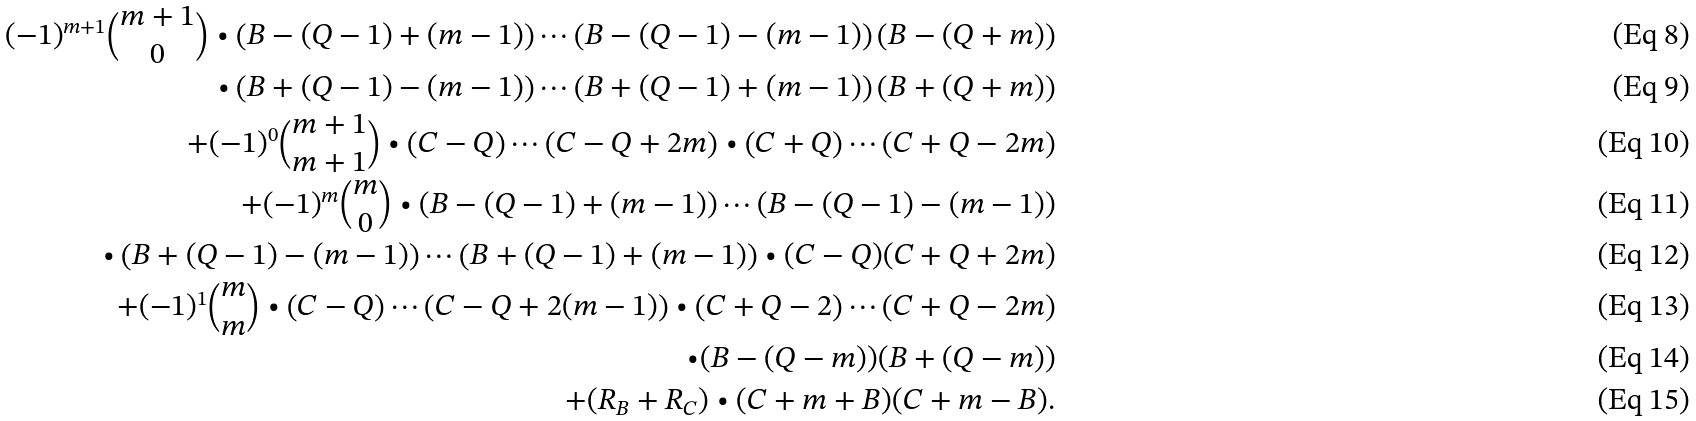Convert formula to latex. <formula><loc_0><loc_0><loc_500><loc_500>( - 1 ) ^ { m + 1 } \binom { m + 1 } { 0 } \bullet \left ( B - ( Q - 1 ) + ( m - 1 ) \right ) \cdots \left ( B - ( Q - 1 ) - ( m - 1 ) \right ) \left ( B - ( Q + m ) \right ) \\ \bullet \left ( B + ( Q - 1 ) - ( m - 1 ) \right ) \cdots \left ( B + ( Q - 1 ) + ( m - 1 ) \right ) \left ( B + ( Q + m ) \right ) \\ + ( - 1 ) ^ { 0 } \binom { m + 1 } { m + 1 } \bullet \left ( C - Q \right ) \cdots \left ( C - Q + 2 m \right ) \bullet \left ( C + Q \right ) \cdots \left ( C + Q - 2 m \right ) \\ + ( - 1 ) ^ { m } \binom { m } { 0 } \bullet \left ( B - ( Q - 1 ) + ( m - 1 ) \right ) \cdots \left ( B - ( Q - 1 ) - ( m - 1 ) \right ) \\ \bullet \left ( B + ( Q - 1 ) - ( m - 1 ) \right ) \cdots \left ( B + ( Q - 1 ) + ( m - 1 ) \right ) \bullet ( C - Q ) ( C + Q + 2 m ) \\ + ( - 1 ) ^ { 1 } \binom { m } { m } \bullet \left ( C - Q \right ) \cdots \left ( C - Q + 2 ( m - 1 ) \right ) \bullet \left ( C + Q - 2 \right ) \cdots \left ( C + Q - 2 m \right ) \\ \bullet ( B - ( Q - m ) ) ( B + ( Q - m ) ) \\ + ( R _ { B } + R _ { C } ) \bullet ( C + m + B ) ( C + m - B ) .</formula> 